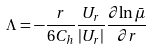<formula> <loc_0><loc_0><loc_500><loc_500>\Lambda = - \frac { r } { 6 C _ { h } } \frac { U _ { r } } { | U _ { r } | } \frac { \partial { \ln \bar { \mu } } } { \partial r }</formula> 